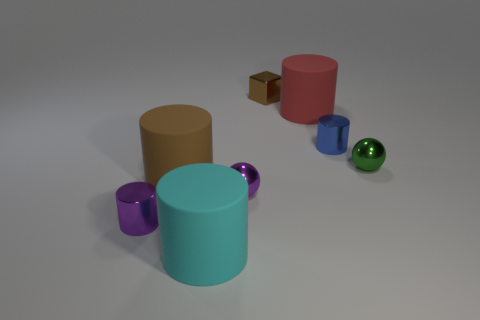Subtract all yellow cylinders. Subtract all blue balls. How many cylinders are left? 5 Add 2 red shiny cylinders. How many objects exist? 10 Subtract all blocks. How many objects are left? 7 Subtract all blue metallic cylinders. Subtract all tiny green metallic cylinders. How many objects are left? 7 Add 1 tiny brown things. How many tiny brown things are left? 2 Add 4 cyan cylinders. How many cyan cylinders exist? 5 Subtract 1 blue cylinders. How many objects are left? 7 